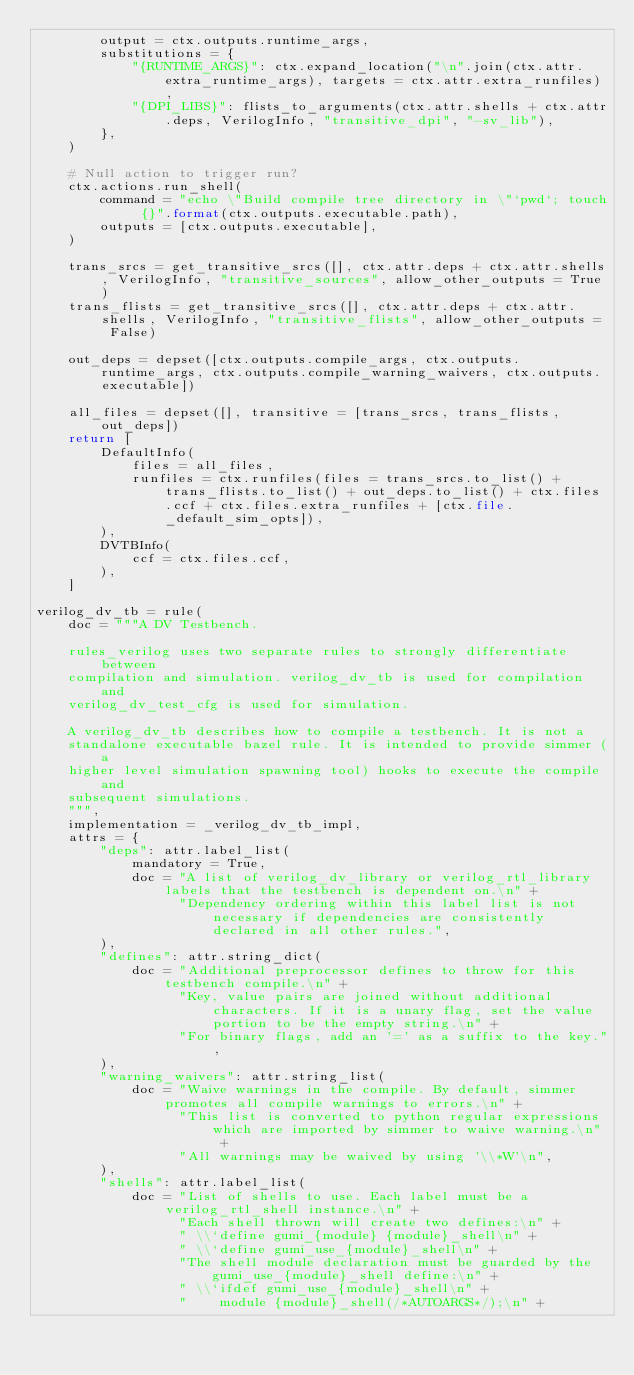<code> <loc_0><loc_0><loc_500><loc_500><_Python_>        output = ctx.outputs.runtime_args,
        substitutions = {
            "{RUNTIME_ARGS}": ctx.expand_location("\n".join(ctx.attr.extra_runtime_args), targets = ctx.attr.extra_runfiles),
            "{DPI_LIBS}": flists_to_arguments(ctx.attr.shells + ctx.attr.deps, VerilogInfo, "transitive_dpi", "-sv_lib"),
        },
    )

    # Null action to trigger run?
    ctx.actions.run_shell(
        command = "echo \"Build compile tree directory in \"`pwd`; touch {}".format(ctx.outputs.executable.path),
        outputs = [ctx.outputs.executable],
    )

    trans_srcs = get_transitive_srcs([], ctx.attr.deps + ctx.attr.shells, VerilogInfo, "transitive_sources", allow_other_outputs = True)
    trans_flists = get_transitive_srcs([], ctx.attr.deps + ctx.attr.shells, VerilogInfo, "transitive_flists", allow_other_outputs = False)

    out_deps = depset([ctx.outputs.compile_args, ctx.outputs.runtime_args, ctx.outputs.compile_warning_waivers, ctx.outputs.executable])

    all_files = depset([], transitive = [trans_srcs, trans_flists, out_deps])
    return [
        DefaultInfo(
            files = all_files,
            runfiles = ctx.runfiles(files = trans_srcs.to_list() + trans_flists.to_list() + out_deps.to_list() + ctx.files.ccf + ctx.files.extra_runfiles + [ctx.file._default_sim_opts]),
        ),
        DVTBInfo(
            ccf = ctx.files.ccf,
        ),
    ]

verilog_dv_tb = rule(
    doc = """A DV Testbench.
    
    rules_verilog uses two separate rules to strongly differentiate between
    compilation and simulation. verilog_dv_tb is used for compilation and    
    verilog_dv_test_cfg is used for simulation.

    A verilog_dv_tb describes how to compile a testbench. It is not a
    standalone executable bazel rule. It is intended to provide simmer (a
    higher level simulation spawning tool) hooks to execute the compile and
    subsequent simulations.
    """,
    implementation = _verilog_dv_tb_impl,
    attrs = {
        "deps": attr.label_list(
            mandatory = True,
            doc = "A list of verilog_dv_library or verilog_rtl_library labels that the testbench is dependent on.\n" +
                  "Dependency ordering within this label list is not necessary if dependencies are consistently declared in all other rules.",
        ),
        "defines": attr.string_dict(
            doc = "Additional preprocessor defines to throw for this testbench compile.\n" +
                  "Key, value pairs are joined without additional characters. If it is a unary flag, set the value portion to be the empty string.\n" +
                  "For binary flags, add an '=' as a suffix to the key.",
        ),
        "warning_waivers": attr.string_list(
            doc = "Waive warnings in the compile. By default, simmer promotes all compile warnings to errors.\n" +
                  "This list is converted to python regular expressions which are imported by simmer to waive warning.\n" +
                  "All warnings may be waived by using '\\*W'\n",
        ),
        "shells": attr.label_list(
            doc = "List of shells to use. Each label must be a verilog_rtl_shell instance.\n" +
                  "Each shell thrown will create two defines:\n" +
                  " \\`define gumi_{module} {module}_shell\n" +
                  " \\`define gumi_use_{module}_shell\n" +
                  "The shell module declaration must be guarded by the gumi_use_{module}_shell define:\n" +
                  " \\`ifdef gumi_use_{module}_shell\n" +
                  "    module {module}_shell(/*AUTOARGS*/);\n" +</code> 